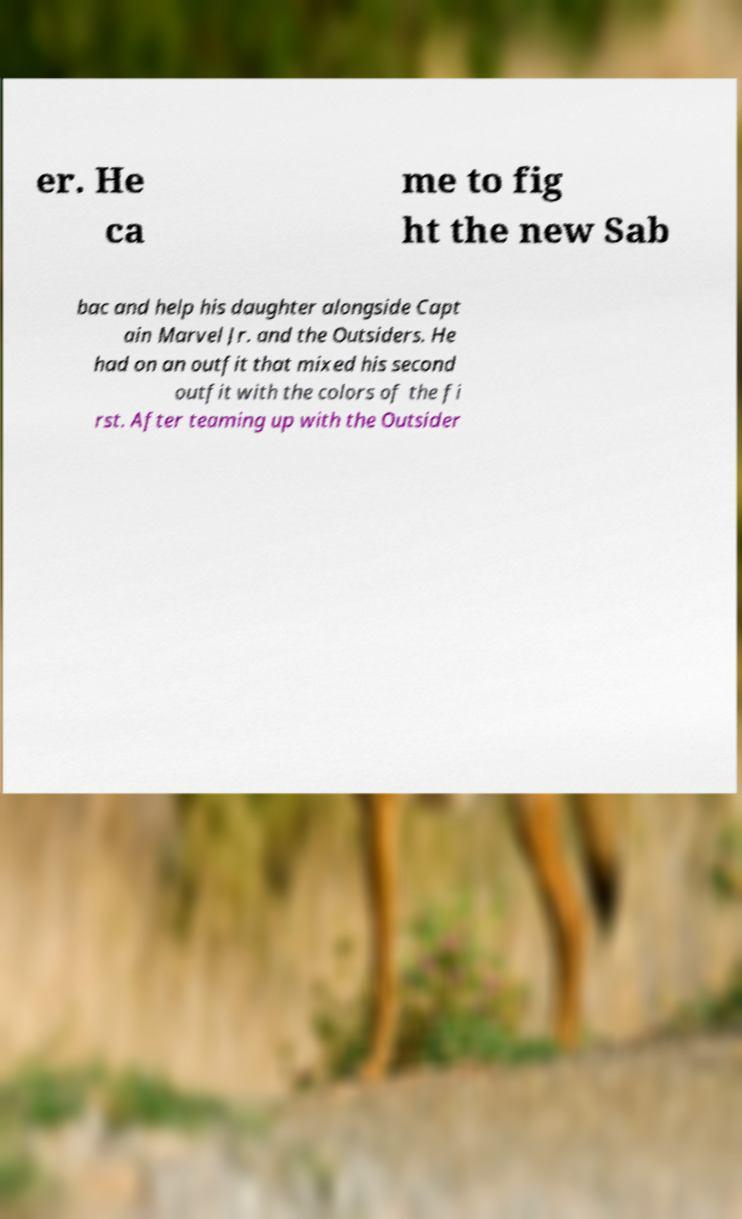Can you read and provide the text displayed in the image?This photo seems to have some interesting text. Can you extract and type it out for me? er. He ca me to fig ht the new Sab bac and help his daughter alongside Capt ain Marvel Jr. and the Outsiders. He had on an outfit that mixed his second outfit with the colors of the fi rst. After teaming up with the Outsider 